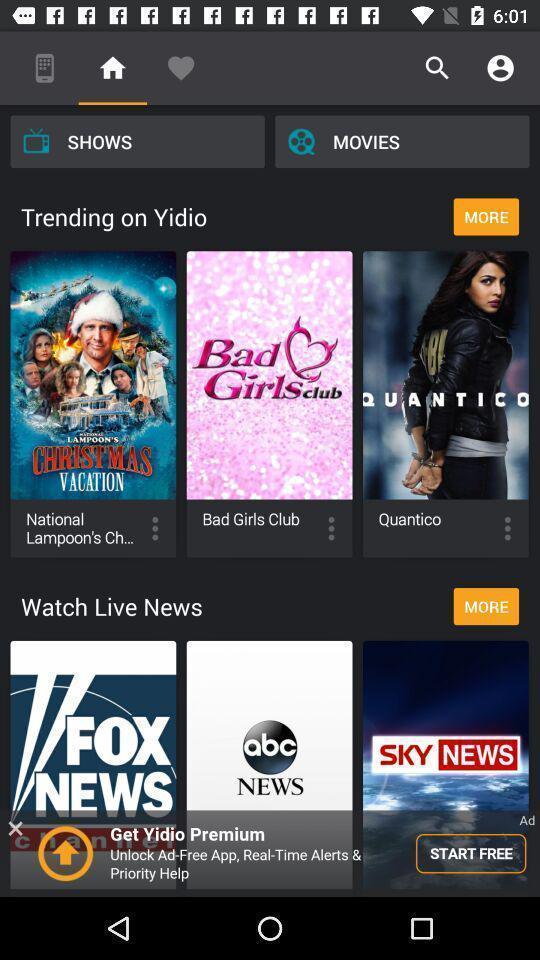Describe the key features of this screenshot. Search bar for different category. 